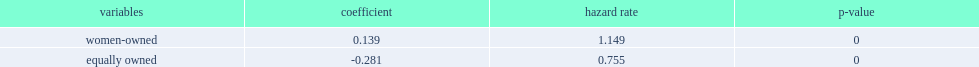Could you help me parse every detail presented in this table? {'header': ['variables', 'coefficient', 'hazard rate', 'p-value'], 'rows': [['women-owned', '0.139', '1.149', '0'], ['equally owned', '-0.281', '0.755', '0']]} What was the percent difference of hazard rates between women-owned firms and men-owned firms? 0.149. 